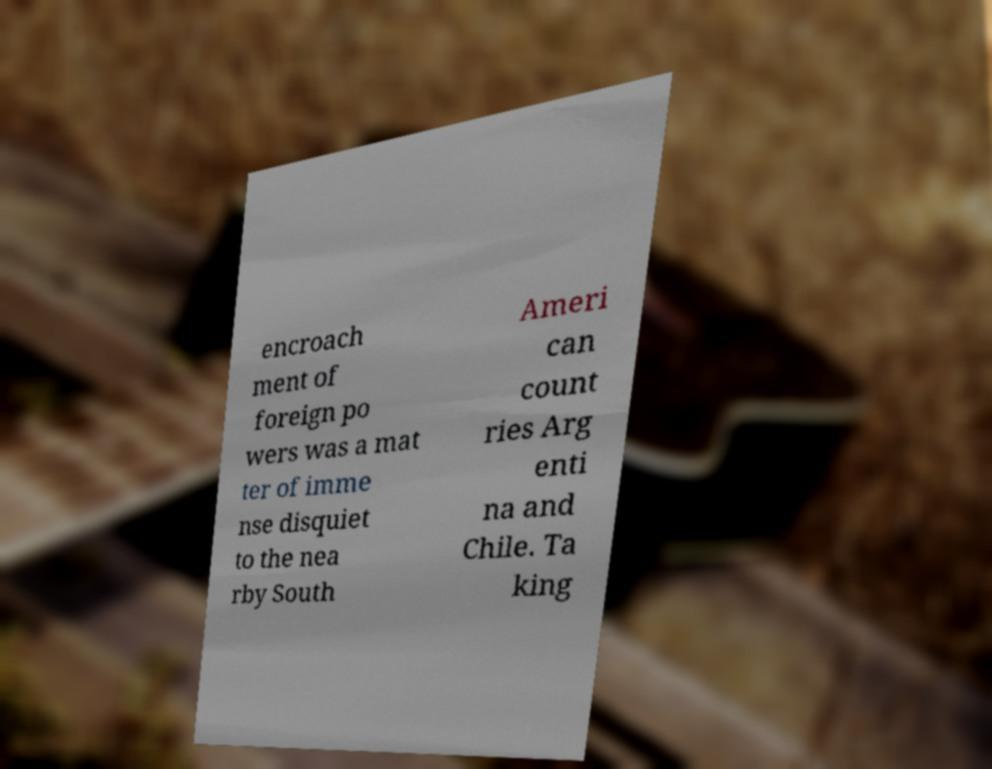Can you accurately transcribe the text from the provided image for me? encroach ment of foreign po wers was a mat ter of imme nse disquiet to the nea rby South Ameri can count ries Arg enti na and Chile. Ta king 